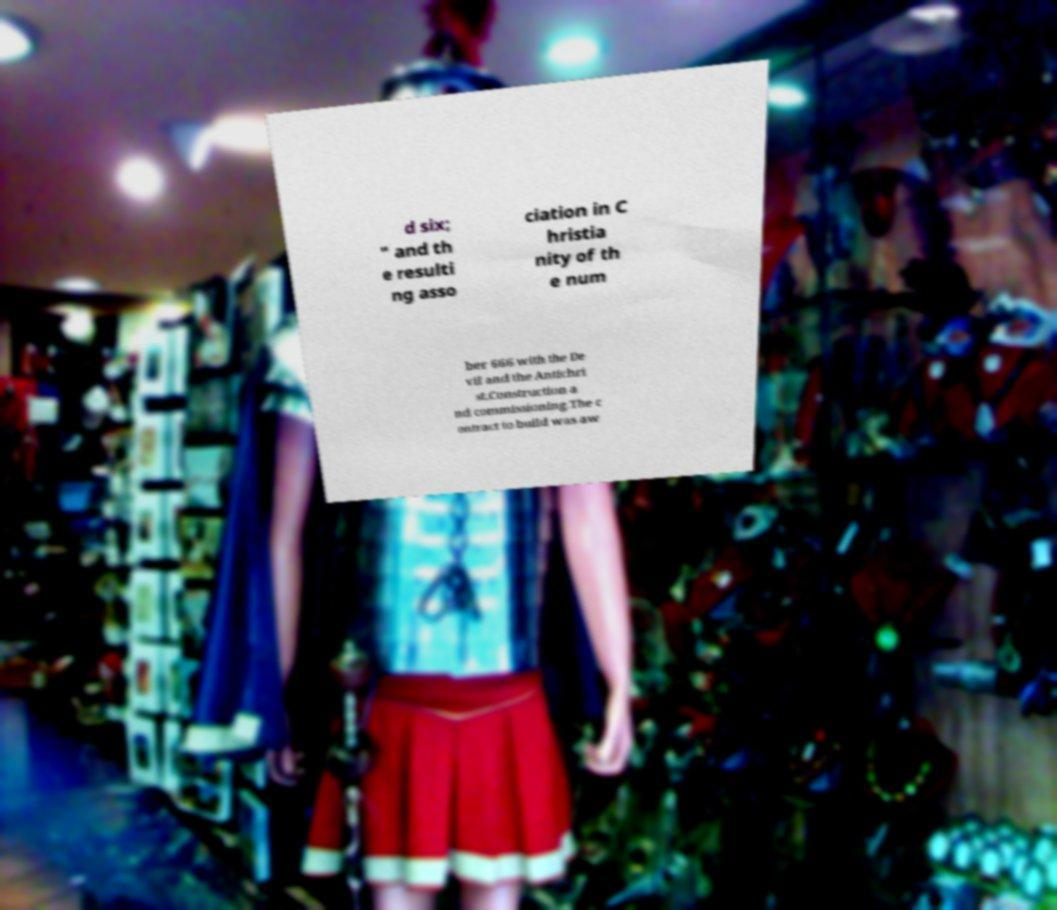Please identify and transcribe the text found in this image. d six; " and th e resulti ng asso ciation in C hristia nity of th e num ber 666 with the De vil and the Antichri st.Construction a nd commissioning.The c ontract to build was aw 